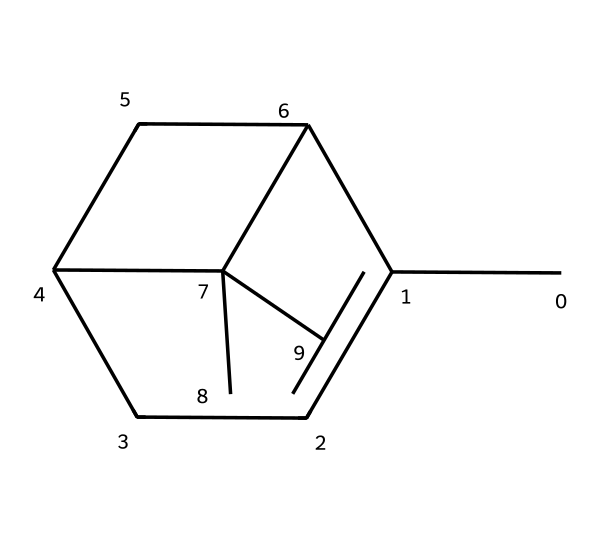What is the total number of carbon atoms in the molecular structure? By examining the SMILES representation, we can count each 'C' symbol, which denotes a carbon atom. There are six 'C' symbols indicating six carbon atoms in the structure.
Answer: six How many double bonds are present in the molecule? In the SMILES, double bonds are represented by the '=' sign. There are no '=' signs in the provided SMILES, indicating that there are no double bonds in the structure.
Answer: zero What type of hydrocarbon is represented by this structure? This structure is a cyclic hydrocarbon since it contains rings and is composed entirely of carbon and hydrogen. The presence of connected cycles supports this classification.
Answer: cyclic Does this chemical likely have a strong or weak odor? Turpentine, which this structure represents, is known for its strong, characteristic odor due to its volatile nature, commonly associated with its use in paint thinners and cleaning products.
Answer: strong What is the likely state of this chemical at room temperature? Given that turpentine is a liquid at room temperature and is used in various applications, we infer its state from its common use as a paint thinner and solvent.
Answer: liquid Can this chemical be considered flammable? This chemical, being turpentine, is a well-known flammable liquid due to its volatile and combustible nature, which is typical for many solvents used in paints and cleaning products.
Answer: yes 